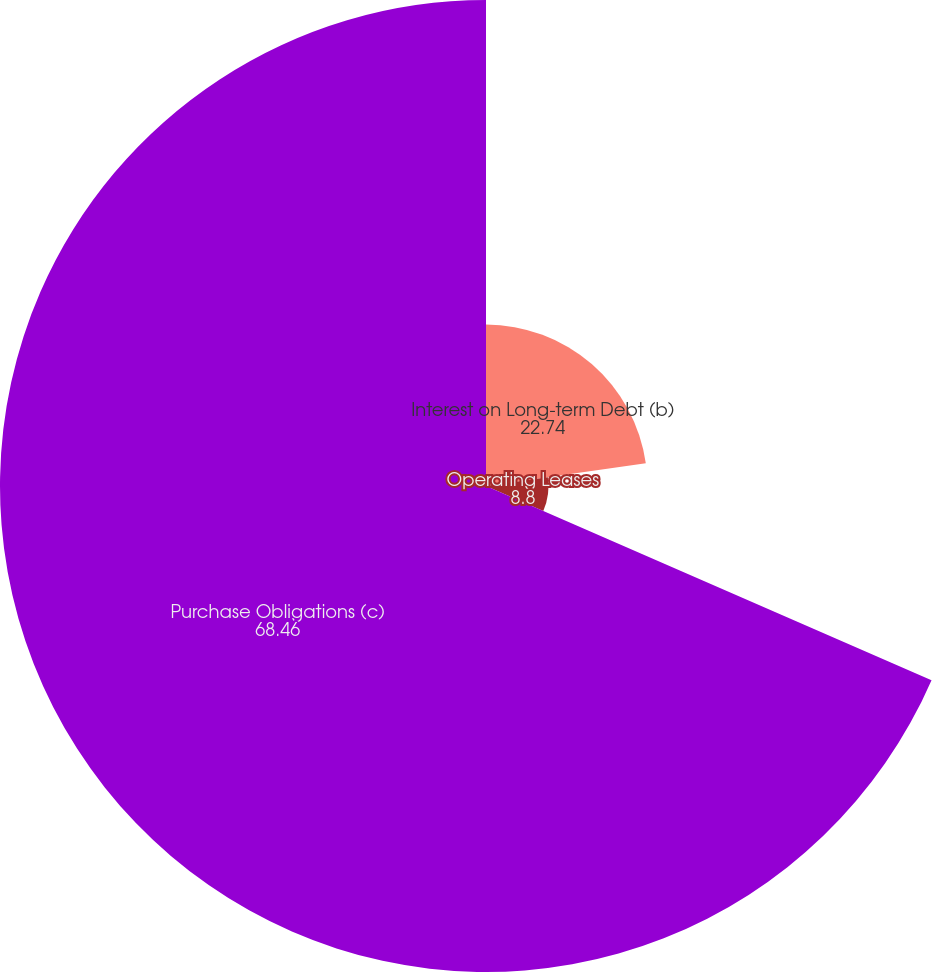Convert chart to OTSL. <chart><loc_0><loc_0><loc_500><loc_500><pie_chart><fcel>Interest on Long-term Debt (b)<fcel>Operating Leases<fcel>Purchase Obligations (c)<nl><fcel>22.74%<fcel>8.8%<fcel>68.46%<nl></chart> 